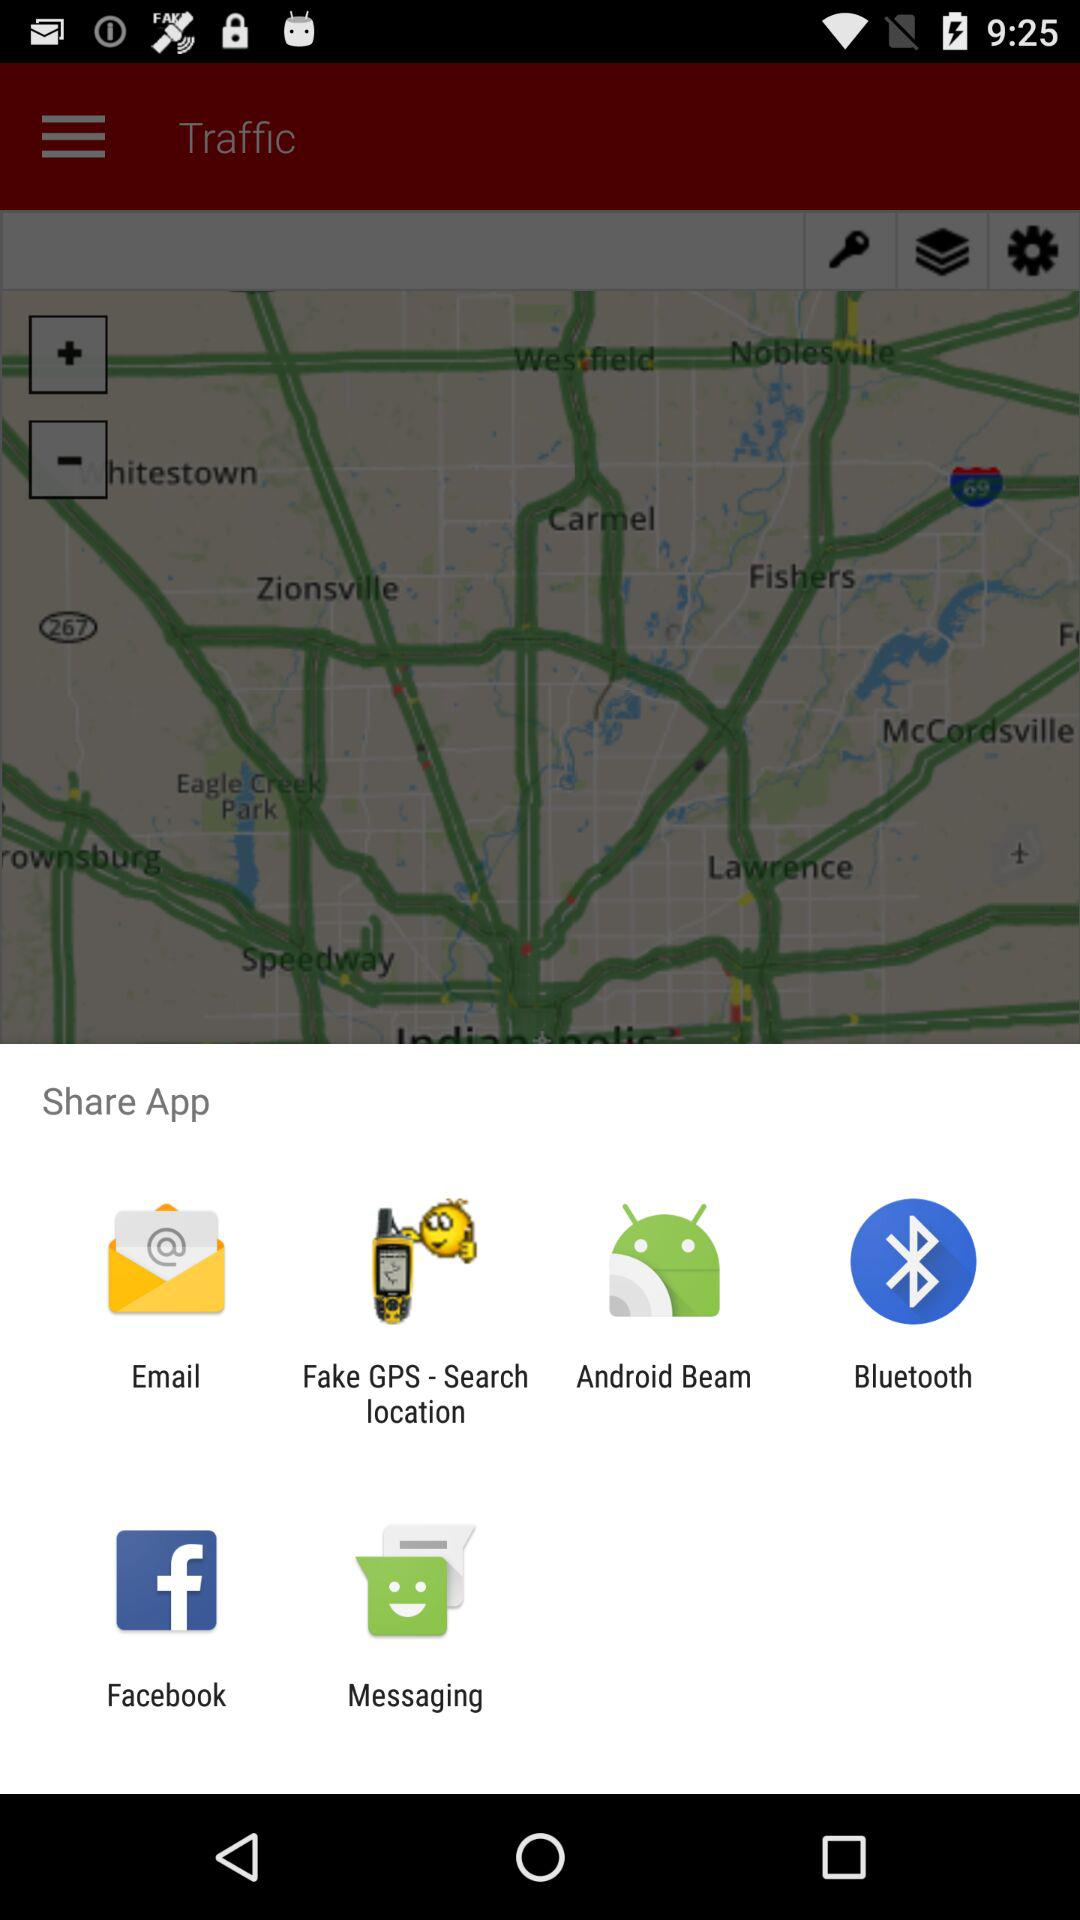Through which application can we share the app? You can share the app through "Email", "Fake GPS - Search location", "Android Beam", "Bluetooth", "Facebook" and "Messaging". 